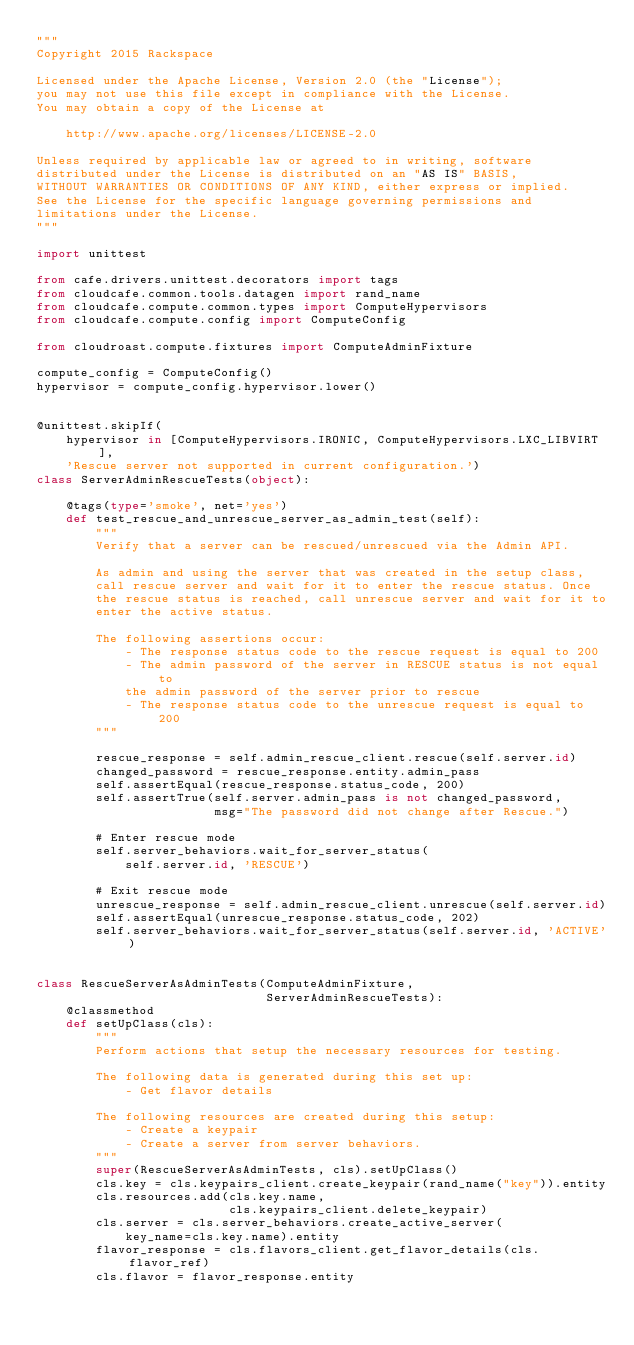<code> <loc_0><loc_0><loc_500><loc_500><_Python_>"""
Copyright 2015 Rackspace

Licensed under the Apache License, Version 2.0 (the "License");
you may not use this file except in compliance with the License.
You may obtain a copy of the License at

    http://www.apache.org/licenses/LICENSE-2.0

Unless required by applicable law or agreed to in writing, software
distributed under the License is distributed on an "AS IS" BASIS,
WITHOUT WARRANTIES OR CONDITIONS OF ANY KIND, either express or implied.
See the License for the specific language governing permissions and
limitations under the License.
"""

import unittest

from cafe.drivers.unittest.decorators import tags
from cloudcafe.common.tools.datagen import rand_name
from cloudcafe.compute.common.types import ComputeHypervisors
from cloudcafe.compute.config import ComputeConfig

from cloudroast.compute.fixtures import ComputeAdminFixture

compute_config = ComputeConfig()
hypervisor = compute_config.hypervisor.lower()


@unittest.skipIf(
    hypervisor in [ComputeHypervisors.IRONIC, ComputeHypervisors.LXC_LIBVIRT],
    'Rescue server not supported in current configuration.')
class ServerAdminRescueTests(object):

    @tags(type='smoke', net='yes')
    def test_rescue_and_unrescue_server_as_admin_test(self):
        """
        Verify that a server can be rescued/unrescued via the Admin API.

        As admin and using the server that was created in the setup class,
        call rescue server and wait for it to enter the rescue status. Once
        the rescue status is reached, call unrescue server and wait for it to
        enter the active status.

        The following assertions occur:
            - The response status code to the rescue request is equal to 200
            - The admin password of the server in RESCUE status is not equal to
            the admin password of the server prior to rescue
            - The response status code to the unrescue request is equal to 200
        """

        rescue_response = self.admin_rescue_client.rescue(self.server.id)
        changed_password = rescue_response.entity.admin_pass
        self.assertEqual(rescue_response.status_code, 200)
        self.assertTrue(self.server.admin_pass is not changed_password,
                        msg="The password did not change after Rescue.")

        # Enter rescue mode
        self.server_behaviors.wait_for_server_status(
            self.server.id, 'RESCUE')

        # Exit rescue mode
        unrescue_response = self.admin_rescue_client.unrescue(self.server.id)
        self.assertEqual(unrescue_response.status_code, 202)
        self.server_behaviors.wait_for_server_status(self.server.id, 'ACTIVE')


class RescueServerAsAdminTests(ComputeAdminFixture,
                               ServerAdminRescueTests):
    @classmethod
    def setUpClass(cls):
        """
        Perform actions that setup the necessary resources for testing.

        The following data is generated during this set up:
            - Get flavor details

        The following resources are created during this setup:
            - Create a keypair
            - Create a server from server behaviors.
        """
        super(RescueServerAsAdminTests, cls).setUpClass()
        cls.key = cls.keypairs_client.create_keypair(rand_name("key")).entity
        cls.resources.add(cls.key.name,
                          cls.keypairs_client.delete_keypair)
        cls.server = cls.server_behaviors.create_active_server(
            key_name=cls.key.name).entity
        flavor_response = cls.flavors_client.get_flavor_details(cls.flavor_ref)
        cls.flavor = flavor_response.entity
</code> 